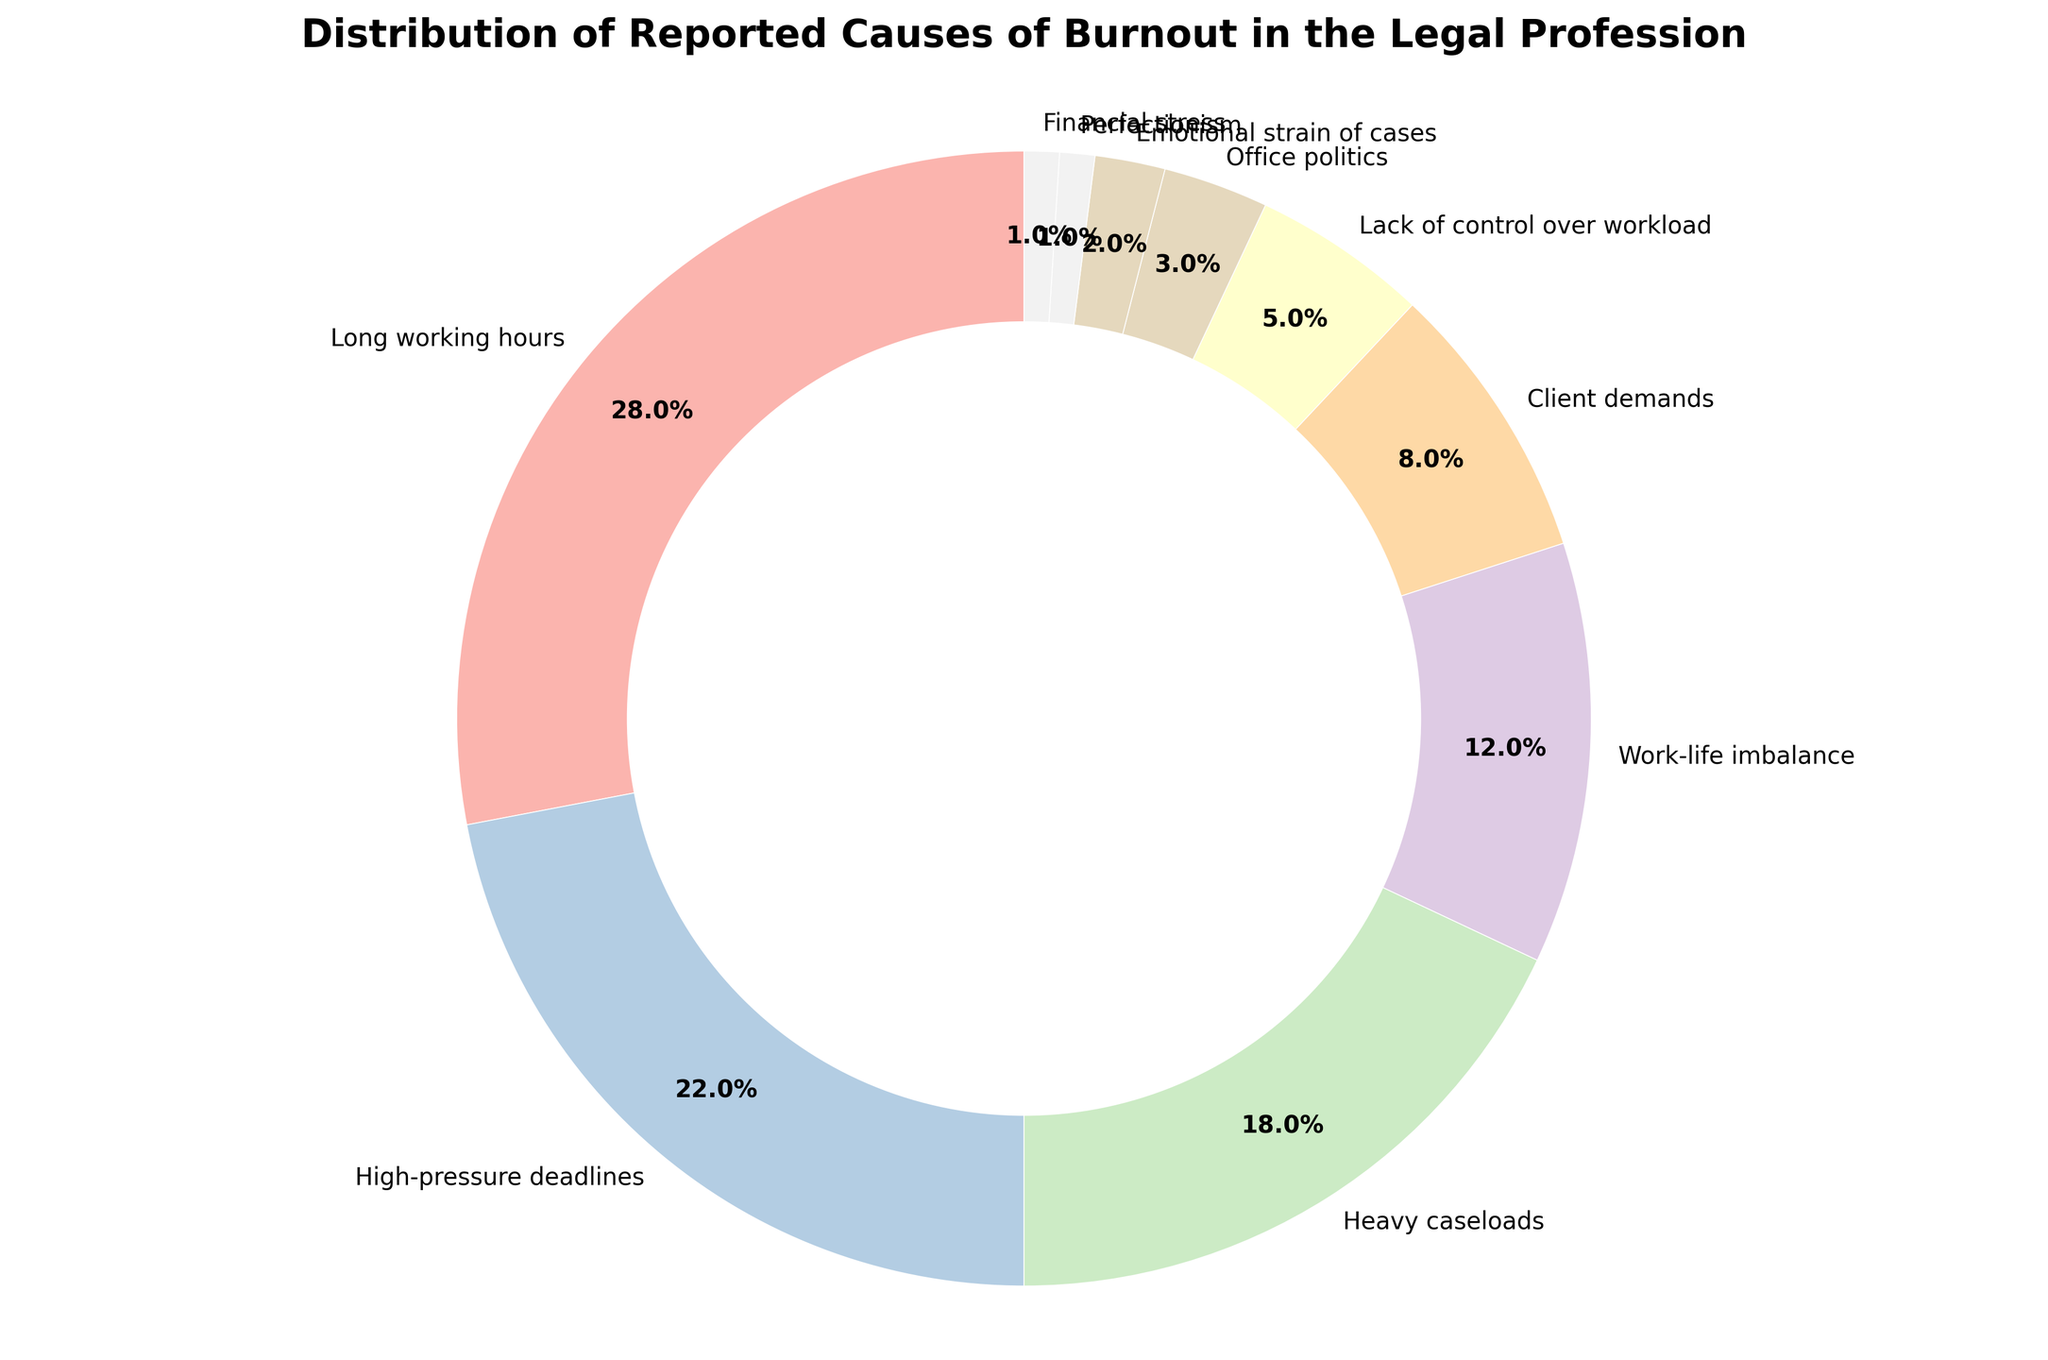What's the largest reported cause of burnout? The pie chart shows various causes of burnout with their corresponding percentages. The largest wedge corresponds to 'Long working hours' at 28%.
Answer: Long working hours Which cause accounts for 18% of the burnout cases? Each segment of the pie chart is labeled with the cause and percentage. The segment labeled 'Heavy caseloads' shows 18%.
Answer: Heavy caseloads Combine the percentages of High-pressure deadlines, Client demands, and Emotional strain of cases. What is the total? The percentages for High-pressure deadlines, Client demands, and Emotional strain of cases are 22%, 8%, and 2% respectively. Adding them gives 22 + 8 + 2 = 32%.
Answer: 32% Which category represents a smaller percentage, Office politics or Financial stress? Comparing the labels, Office politics is 3% and Financial stress is 1%. Financial stress is a smaller percentage.
Answer: Financial stress What proportion of the total burnout causes is attributed to Work-life imbalance compared to Lack of control over workload? Work-life imbalance is 12% and Lack of control over workload is 5%. To find the proportion, we divide 12 by 5, giving 12/5 = 2.4.
Answer: 2.4 How many causes have a percentage lower than 5%? By examining the pie chart, the causes with percentages lower than 5% are Lack of control over workload (5%), Office politics (3%), Emotional strain of cases (2%), Perfectionism (1%), and Financial stress (1%). Thus, there are 5 causes.
Answer: 5 causes If the categories 'Client demands' and 'Perfectionism' were combined into a single category, what percentage would this new category represent? The percentages for Client demands and Perfectionism are 8% and 1% respectively. Adding them gives 8 + 1 = 9%.
Answer: 9% Is the percentage of burnout caused by Heavy caseloads greater than the sum of Office politics and Financial stress percentages? Heavy caseloads is 18%. The sum of Office politics (3%) and Financial stress (1%) is 3 + 1 = 4%. Since 18% > 4%, Heavy caseloads have a greater percentage.
Answer: Yes What is the difference in percentage between Long working hours and High-pressure deadlines? Long working hours is 28%, and High-pressure deadlines is 22%. The difference is 28 - 22 = 6%.
Answer: 6% Which two causes together account for 30% of the burnout cases? By evaluating combinations, the sum of 'Heavy caseloads' (18%) and 'Work-life imbalance' (12%) equals 18 + 12 = 30%.
Answer: Heavy caseloads and Work-life imbalance 